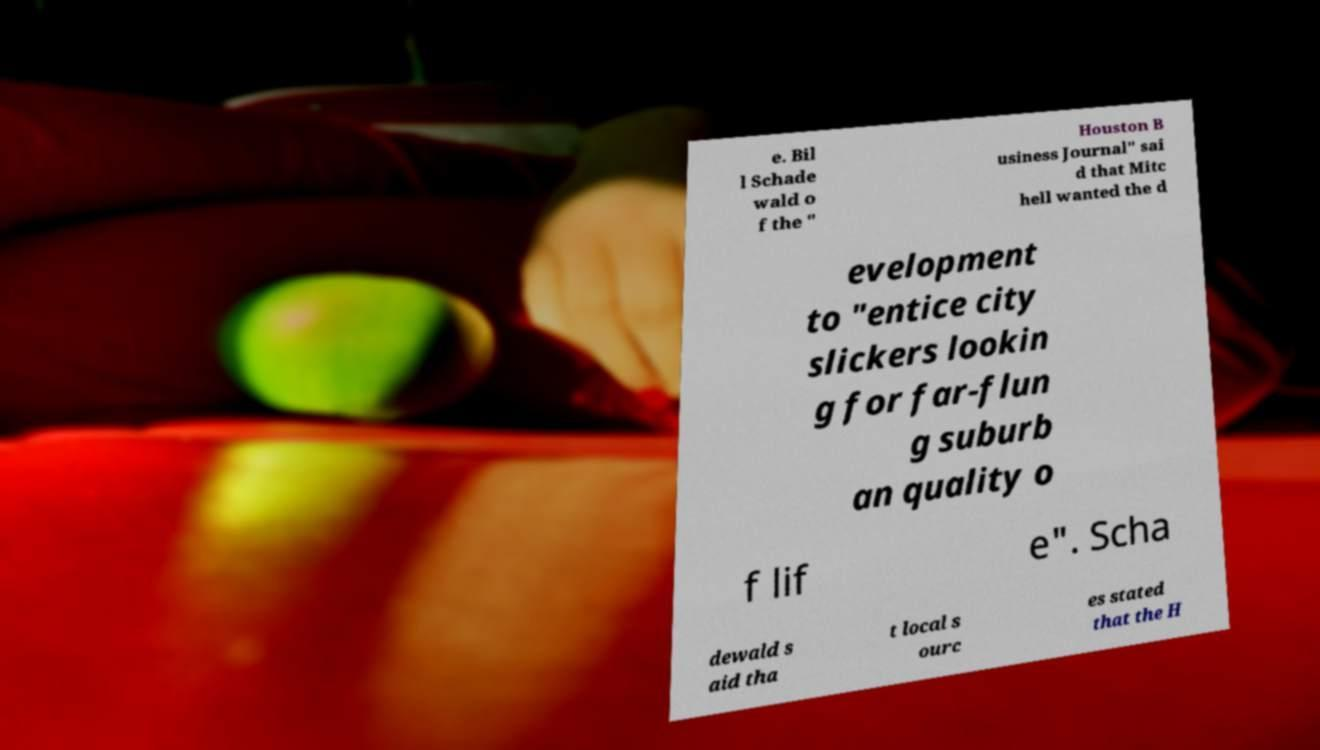There's text embedded in this image that I need extracted. Can you transcribe it verbatim? e. Bil l Schade wald o f the " Houston B usiness Journal" sai d that Mitc hell wanted the d evelopment to "entice city slickers lookin g for far-flun g suburb an quality o f lif e". Scha dewald s aid tha t local s ourc es stated that the H 